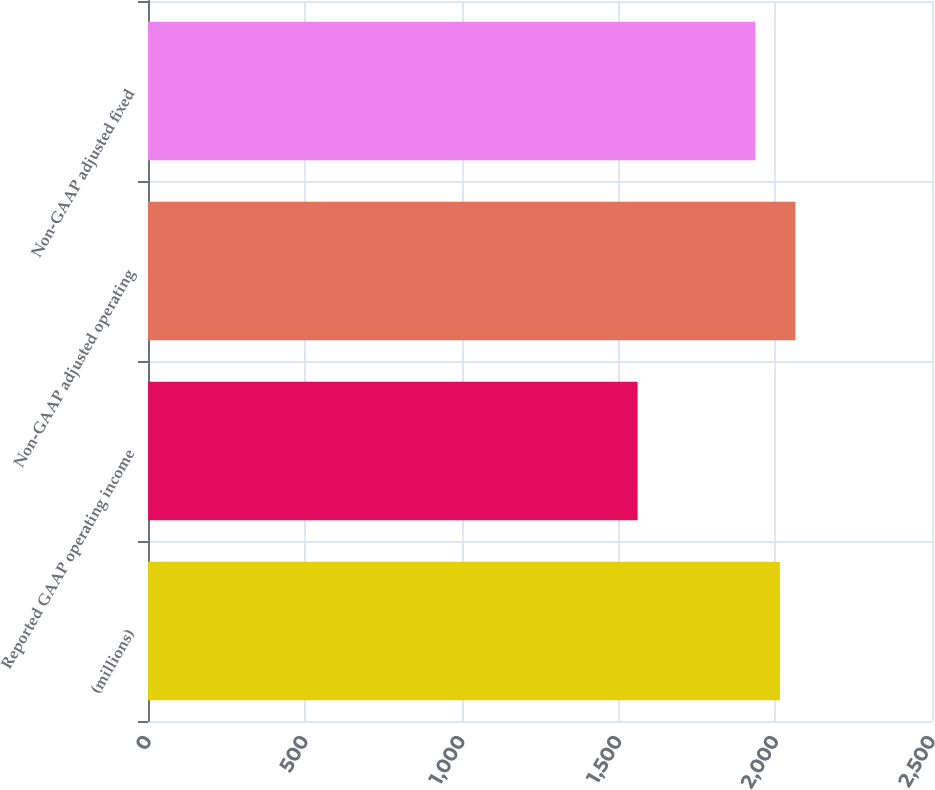Convert chart to OTSL. <chart><loc_0><loc_0><loc_500><loc_500><bar_chart><fcel>(millions)<fcel>Reported GAAP operating income<fcel>Non-GAAP adjusted operating<fcel>Non-GAAP adjusted fixed<nl><fcel>2015<fcel>1561.3<fcel>2064.54<fcel>1936.9<nl></chart> 